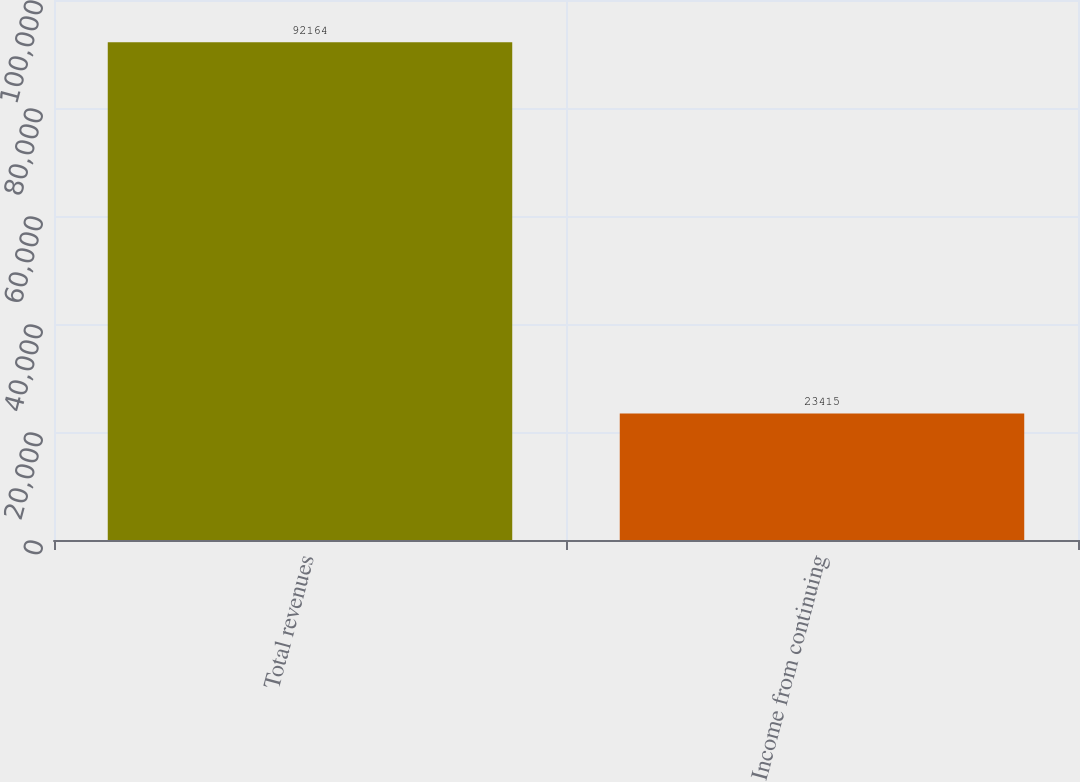Convert chart. <chart><loc_0><loc_0><loc_500><loc_500><bar_chart><fcel>Total revenues<fcel>Income from continuing<nl><fcel>92164<fcel>23415<nl></chart> 